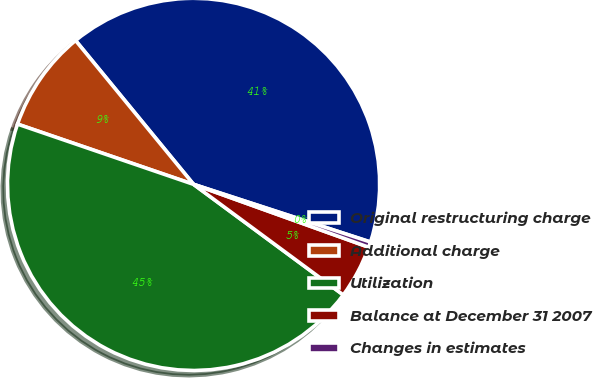Convert chart to OTSL. <chart><loc_0><loc_0><loc_500><loc_500><pie_chart><fcel>Original restructuring charge<fcel>Additional charge<fcel>Utilization<fcel>Balance at December 31 2007<fcel>Changes in estimates<nl><fcel>40.95%<fcel>8.82%<fcel>45.13%<fcel>4.64%<fcel>0.47%<nl></chart> 